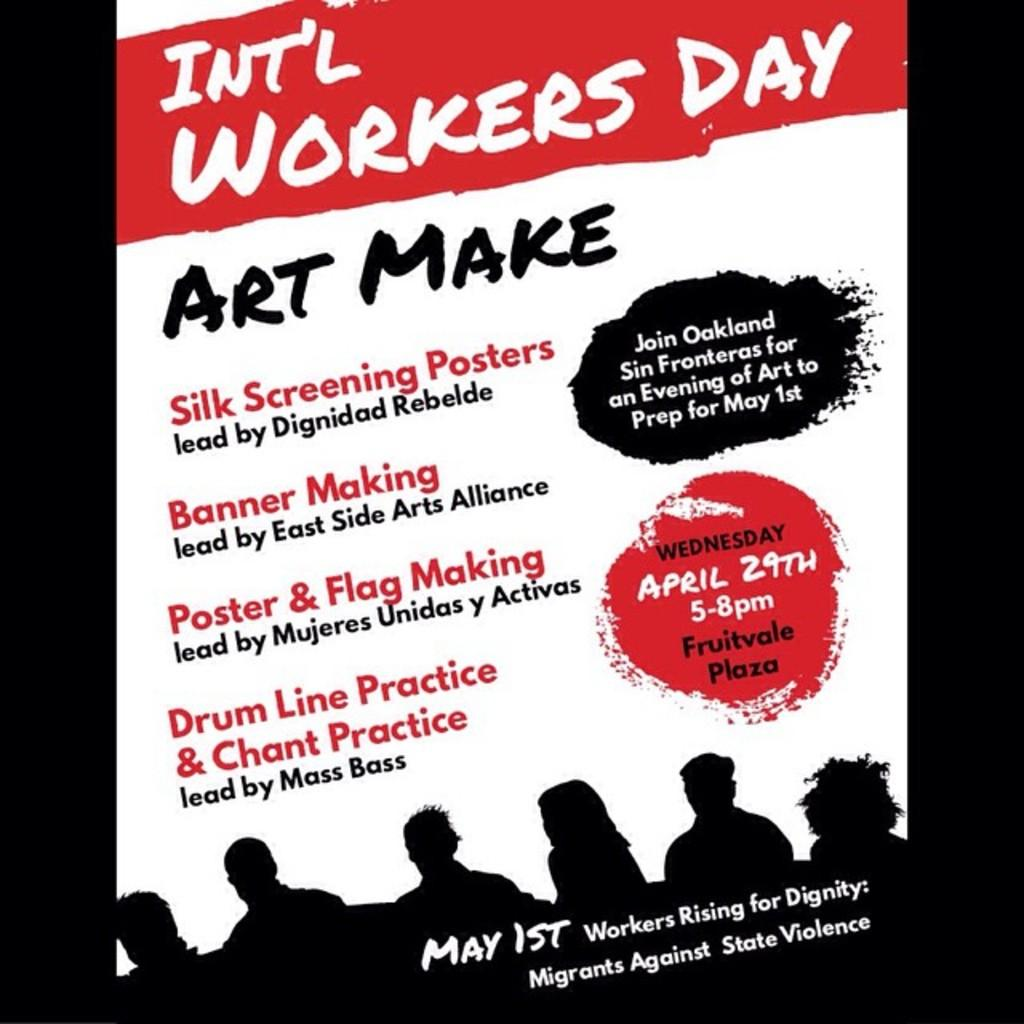What is the main subject of the image? The main subject of the image is a poster. What can be seen on the poster? There is writing on the poster and a depiction of persons. How many legs can be seen on the poster? There is no information about legs in the image, as it only features a poster with writing and a depiction of persons. 